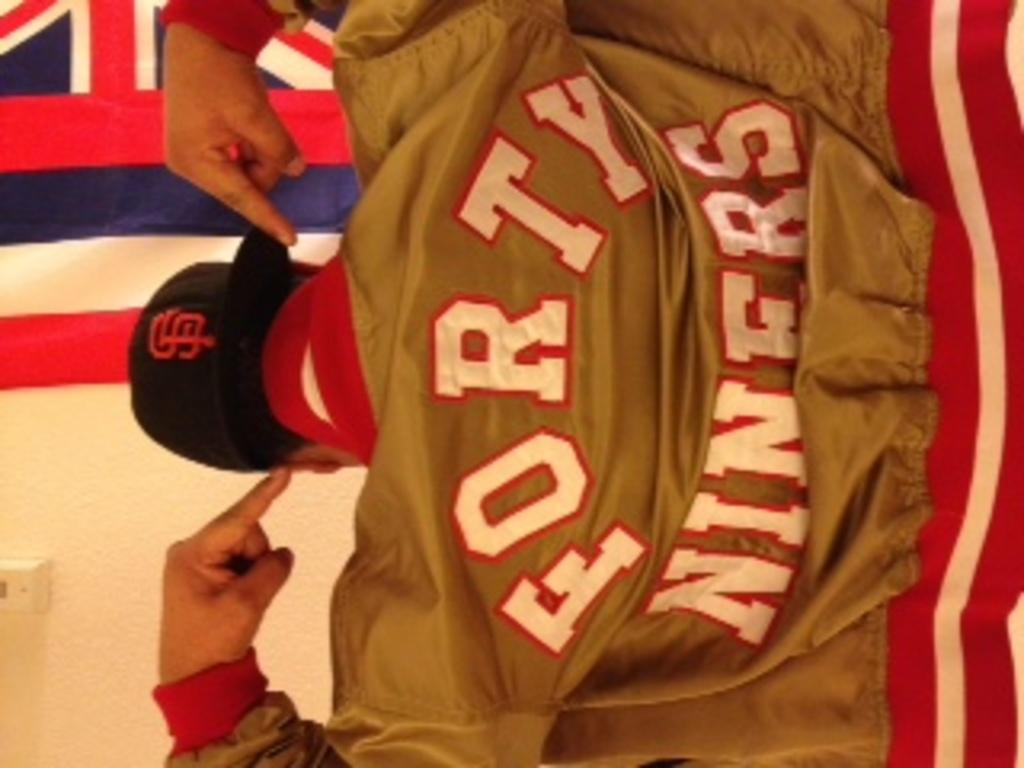<image>
Render a clear and concise summary of the photo. a person pointing to their jacket that says forty 